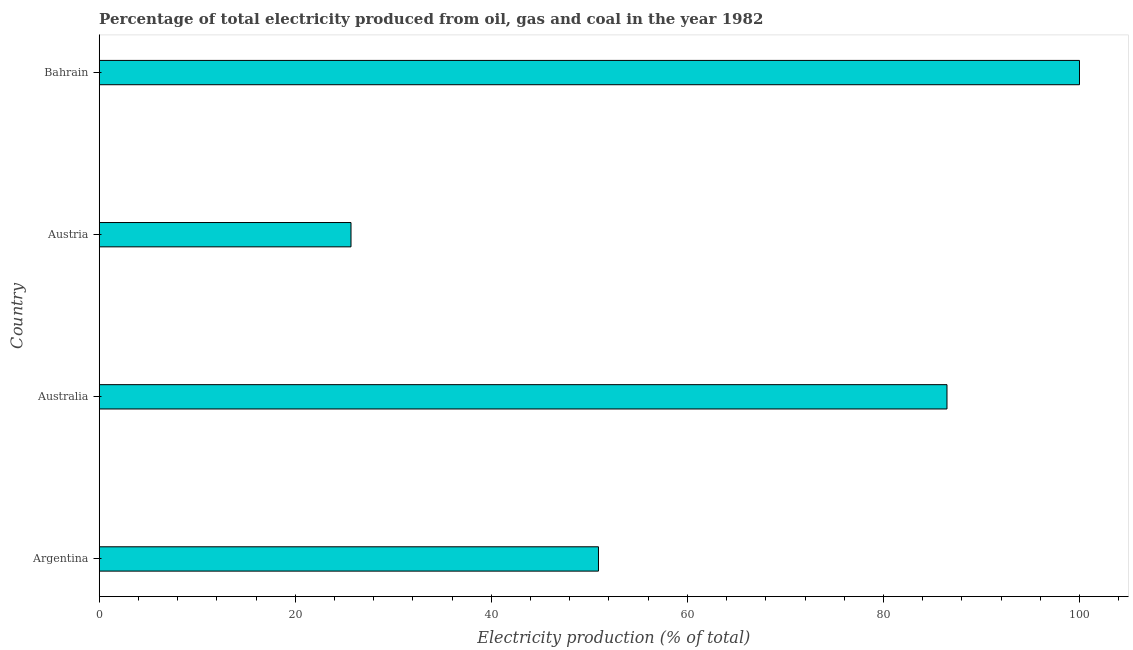Does the graph contain grids?
Keep it short and to the point. No. What is the title of the graph?
Provide a succinct answer. Percentage of total electricity produced from oil, gas and coal in the year 1982. What is the label or title of the X-axis?
Your answer should be compact. Electricity production (% of total). What is the label or title of the Y-axis?
Give a very brief answer. Country. What is the electricity production in Austria?
Make the answer very short. 25.68. Across all countries, what is the minimum electricity production?
Your answer should be compact. 25.68. In which country was the electricity production maximum?
Your response must be concise. Bahrain. In which country was the electricity production minimum?
Keep it short and to the point. Austria. What is the sum of the electricity production?
Give a very brief answer. 263.1. What is the difference between the electricity production in Argentina and Australia?
Offer a very short reply. -35.55. What is the average electricity production per country?
Your answer should be very brief. 65.78. What is the median electricity production?
Give a very brief answer. 68.71. What is the ratio of the electricity production in Argentina to that in Bahrain?
Keep it short and to the point. 0.51. Is the difference between the electricity production in Argentina and Austria greater than the difference between any two countries?
Give a very brief answer. No. What is the difference between the highest and the second highest electricity production?
Offer a very short reply. 13.52. Is the sum of the electricity production in Australia and Bahrain greater than the maximum electricity production across all countries?
Your response must be concise. Yes. What is the difference between the highest and the lowest electricity production?
Offer a terse response. 74.32. In how many countries, is the electricity production greater than the average electricity production taken over all countries?
Your response must be concise. 2. How many countries are there in the graph?
Keep it short and to the point. 4. What is the difference between two consecutive major ticks on the X-axis?
Your answer should be compact. 20. Are the values on the major ticks of X-axis written in scientific E-notation?
Make the answer very short. No. What is the Electricity production (% of total) of Argentina?
Give a very brief answer. 50.93. What is the Electricity production (% of total) in Australia?
Your answer should be very brief. 86.48. What is the Electricity production (% of total) of Austria?
Provide a succinct answer. 25.68. What is the Electricity production (% of total) in Bahrain?
Your answer should be compact. 100. What is the difference between the Electricity production (% of total) in Argentina and Australia?
Provide a succinct answer. -35.55. What is the difference between the Electricity production (% of total) in Argentina and Austria?
Ensure brevity in your answer.  25.25. What is the difference between the Electricity production (% of total) in Argentina and Bahrain?
Offer a terse response. -49.07. What is the difference between the Electricity production (% of total) in Australia and Austria?
Offer a terse response. 60.8. What is the difference between the Electricity production (% of total) in Australia and Bahrain?
Your answer should be compact. -13.52. What is the difference between the Electricity production (% of total) in Austria and Bahrain?
Your response must be concise. -74.32. What is the ratio of the Electricity production (% of total) in Argentina to that in Australia?
Offer a terse response. 0.59. What is the ratio of the Electricity production (% of total) in Argentina to that in Austria?
Keep it short and to the point. 1.98. What is the ratio of the Electricity production (% of total) in Argentina to that in Bahrain?
Ensure brevity in your answer.  0.51. What is the ratio of the Electricity production (% of total) in Australia to that in Austria?
Give a very brief answer. 3.37. What is the ratio of the Electricity production (% of total) in Australia to that in Bahrain?
Ensure brevity in your answer.  0.86. What is the ratio of the Electricity production (% of total) in Austria to that in Bahrain?
Make the answer very short. 0.26. 